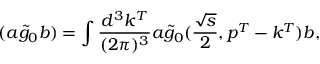<formula> <loc_0><loc_0><loc_500><loc_500>( a \widetilde { g } _ { 0 } b ) = \int \frac { d ^ { 3 } k ^ { T } } { ( 2 \pi ) ^ { 3 } } a \widetilde { g } _ { 0 } ( \frac { \sqrt { s } } { 2 } , p ^ { T } - k ^ { T } ) b ,</formula> 